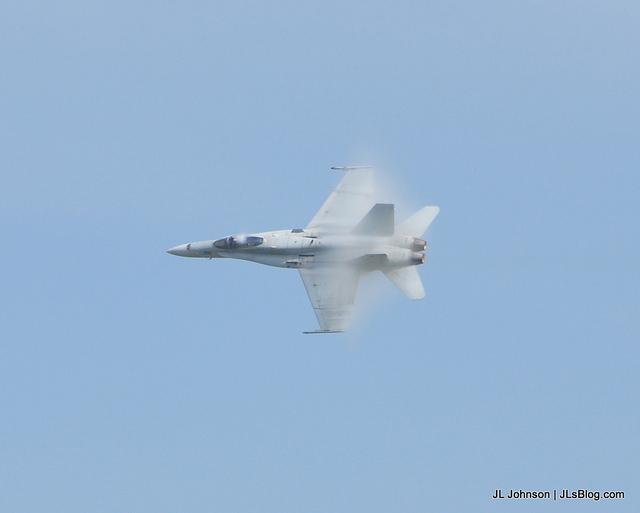How many ovens are there?
Give a very brief answer. 0. 